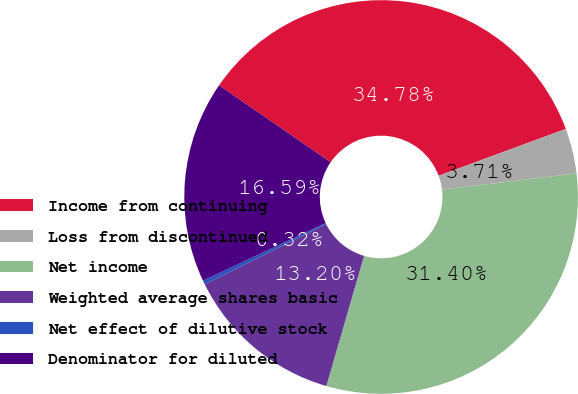Convert chart. <chart><loc_0><loc_0><loc_500><loc_500><pie_chart><fcel>Income from continuing<fcel>Loss from discontinued<fcel>Net income<fcel>Weighted average shares basic<fcel>Net effect of dilutive stock<fcel>Denominator for diluted<nl><fcel>34.78%<fcel>3.71%<fcel>31.4%<fcel>13.2%<fcel>0.32%<fcel>16.59%<nl></chart> 